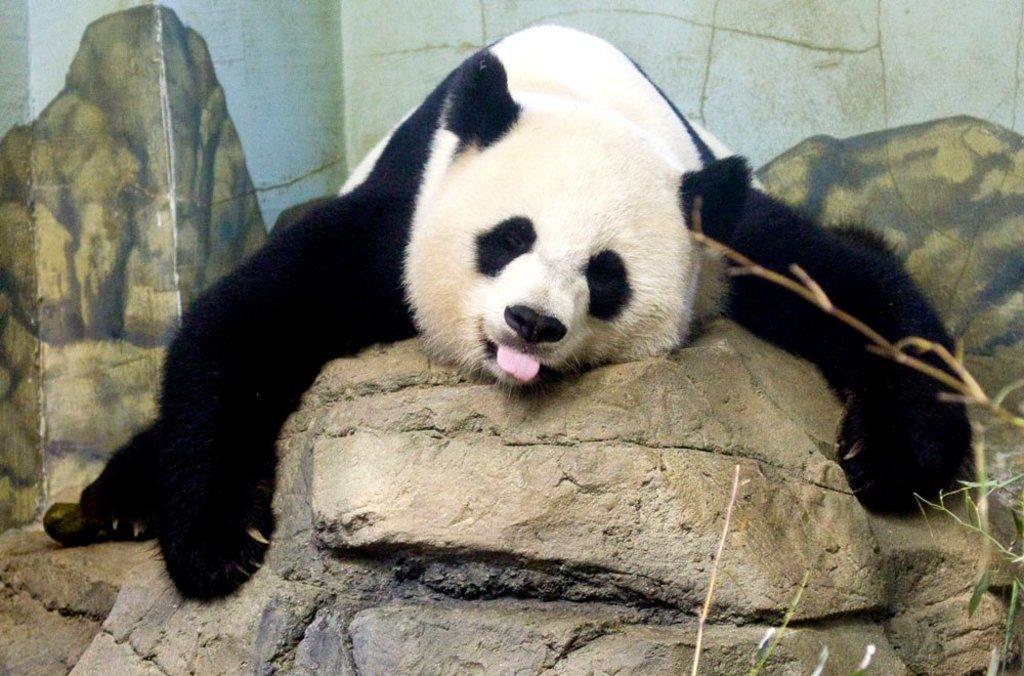Can you describe this image briefly? In this image we can see a panda and the panda is lying on a rock. Behind the panda we can see a wall. On the wall we can see the painting of mountains. In the bottom right we can see the grass. 